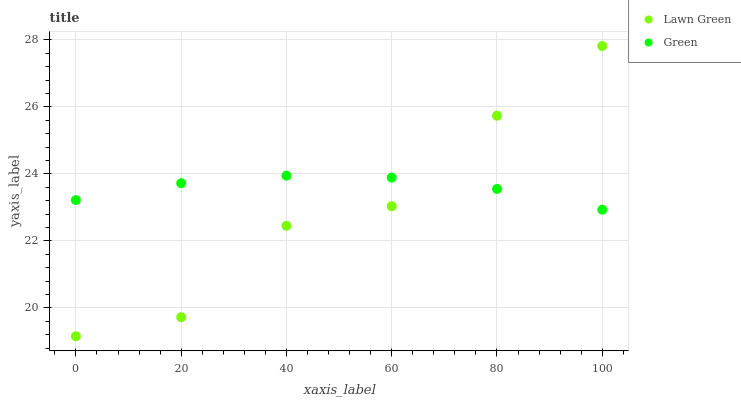Does Lawn Green have the minimum area under the curve?
Answer yes or no. Yes. Does Green have the maximum area under the curve?
Answer yes or no. Yes. Does Green have the minimum area under the curve?
Answer yes or no. No. Is Green the smoothest?
Answer yes or no. Yes. Is Lawn Green the roughest?
Answer yes or no. Yes. Is Green the roughest?
Answer yes or no. No. Does Lawn Green have the lowest value?
Answer yes or no. Yes. Does Green have the lowest value?
Answer yes or no. No. Does Lawn Green have the highest value?
Answer yes or no. Yes. Does Green have the highest value?
Answer yes or no. No. Does Lawn Green intersect Green?
Answer yes or no. Yes. Is Lawn Green less than Green?
Answer yes or no. No. Is Lawn Green greater than Green?
Answer yes or no. No. 